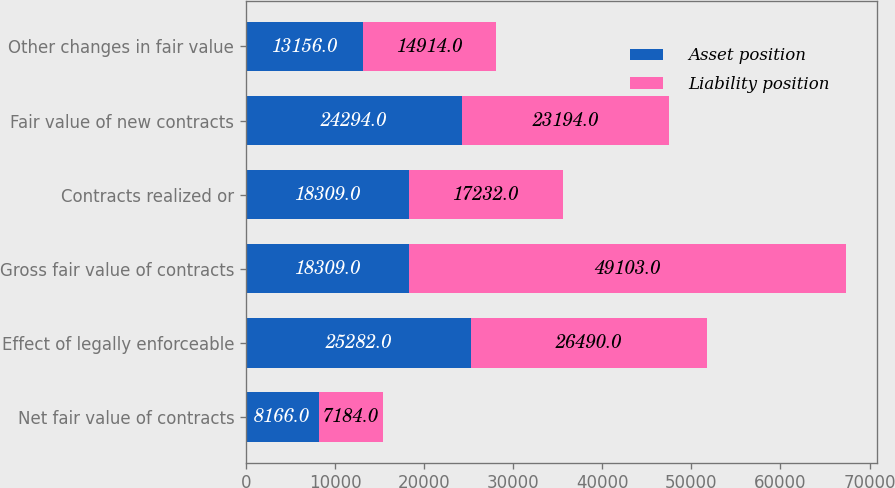<chart> <loc_0><loc_0><loc_500><loc_500><stacked_bar_chart><ecel><fcel>Net fair value of contracts<fcel>Effect of legally enforceable<fcel>Gross fair value of contracts<fcel>Contracts realized or<fcel>Fair value of new contracts<fcel>Other changes in fair value<nl><fcel>Asset position<fcel>8166<fcel>25282<fcel>18309<fcel>18309<fcel>24294<fcel>13156<nl><fcel>Liability position<fcel>7184<fcel>26490<fcel>49103<fcel>17232<fcel>23194<fcel>14914<nl></chart> 